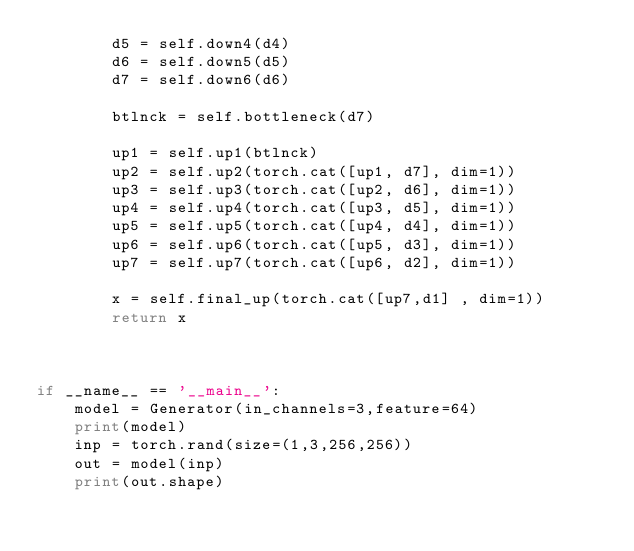<code> <loc_0><loc_0><loc_500><loc_500><_Python_>        d5 = self.down4(d4)
        d6 = self.down5(d5)
        d7 = self.down6(d6)

        btlnck = self.bottleneck(d7)

        up1 = self.up1(btlnck)
        up2 = self.up2(torch.cat([up1, d7], dim=1))
        up3 = self.up3(torch.cat([up2, d6], dim=1))
        up4 = self.up4(torch.cat([up3, d5], dim=1))
        up5 = self.up5(torch.cat([up4, d4], dim=1))
        up6 = self.up6(torch.cat([up5, d3], dim=1))
        up7 = self.up7(torch.cat([up6, d2], dim=1))

        x = self.final_up(torch.cat([up7,d1] , dim=1))
        return x



if __name__ == '__main__':
    model = Generator(in_channels=3,feature=64)
    print(model)
    inp = torch.rand(size=(1,3,256,256))
    out = model(inp)
    print(out.shape)</code> 